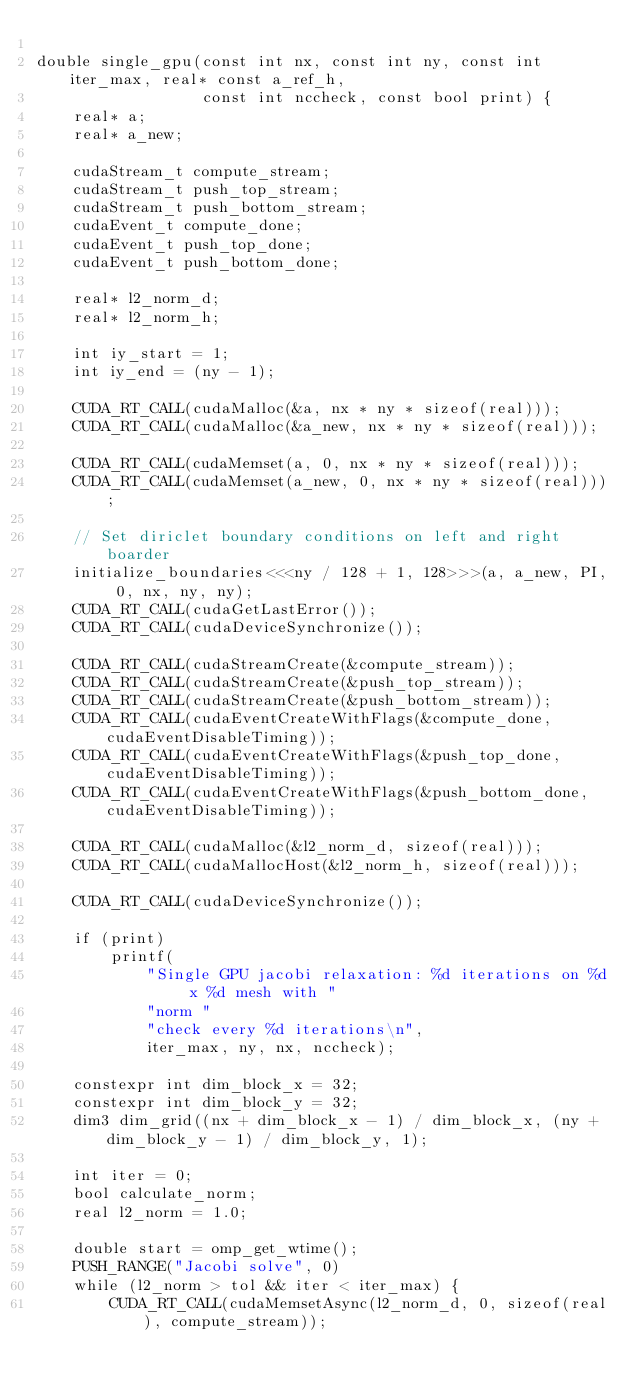Convert code to text. <code><loc_0><loc_0><loc_500><loc_500><_Cuda_>
double single_gpu(const int nx, const int ny, const int iter_max, real* const a_ref_h,
                  const int nccheck, const bool print) {
    real* a;
    real* a_new;

    cudaStream_t compute_stream;
    cudaStream_t push_top_stream;
    cudaStream_t push_bottom_stream;
    cudaEvent_t compute_done;
    cudaEvent_t push_top_done;
    cudaEvent_t push_bottom_done;

    real* l2_norm_d;
    real* l2_norm_h;

    int iy_start = 1;
    int iy_end = (ny - 1);

    CUDA_RT_CALL(cudaMalloc(&a, nx * ny * sizeof(real)));
    CUDA_RT_CALL(cudaMalloc(&a_new, nx * ny * sizeof(real)));

    CUDA_RT_CALL(cudaMemset(a, 0, nx * ny * sizeof(real)));
    CUDA_RT_CALL(cudaMemset(a_new, 0, nx * ny * sizeof(real)));

    // Set diriclet boundary conditions on left and right boarder
    initialize_boundaries<<<ny / 128 + 1, 128>>>(a, a_new, PI, 0, nx, ny, ny);
    CUDA_RT_CALL(cudaGetLastError());
    CUDA_RT_CALL(cudaDeviceSynchronize());

    CUDA_RT_CALL(cudaStreamCreate(&compute_stream));
    CUDA_RT_CALL(cudaStreamCreate(&push_top_stream));
    CUDA_RT_CALL(cudaStreamCreate(&push_bottom_stream));
    CUDA_RT_CALL(cudaEventCreateWithFlags(&compute_done, cudaEventDisableTiming));
    CUDA_RT_CALL(cudaEventCreateWithFlags(&push_top_done, cudaEventDisableTiming));
    CUDA_RT_CALL(cudaEventCreateWithFlags(&push_bottom_done, cudaEventDisableTiming));

    CUDA_RT_CALL(cudaMalloc(&l2_norm_d, sizeof(real)));
    CUDA_RT_CALL(cudaMallocHost(&l2_norm_h, sizeof(real)));

    CUDA_RT_CALL(cudaDeviceSynchronize());

    if (print)
        printf(
            "Single GPU jacobi relaxation: %d iterations on %d x %d mesh with "
            "norm "
            "check every %d iterations\n",
            iter_max, ny, nx, nccheck);

    constexpr int dim_block_x = 32;
    constexpr int dim_block_y = 32;
    dim3 dim_grid((nx + dim_block_x - 1) / dim_block_x, (ny + dim_block_y - 1) / dim_block_y, 1);

    int iter = 0;
    bool calculate_norm;
    real l2_norm = 1.0;

    double start = omp_get_wtime();
    PUSH_RANGE("Jacobi solve", 0)
    while (l2_norm > tol && iter < iter_max) {
        CUDA_RT_CALL(cudaMemsetAsync(l2_norm_d, 0, sizeof(real), compute_stream));
</code> 